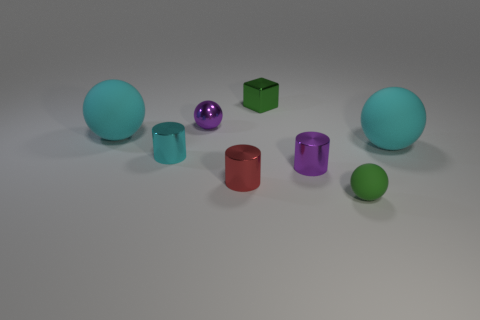There is a metal block that is the same color as the tiny rubber thing; what is its size?
Your answer should be compact. Small. Is there a large cyan object that has the same shape as the tiny cyan object?
Keep it short and to the point. No. What color is the metal ball that is the same size as the green matte sphere?
Keep it short and to the point. Purple. Is the number of small cyan metal things right of the green shiny object less than the number of small green objects to the right of the purple metal cylinder?
Make the answer very short. Yes. Is the size of the object behind the purple metal sphere the same as the tiny cyan thing?
Make the answer very short. Yes. There is a tiny object that is in front of the tiny red metal cylinder; what is its shape?
Give a very brief answer. Sphere. Are there more small cubes than objects?
Offer a terse response. No. Is the color of the object that is behind the purple metallic ball the same as the small matte object?
Make the answer very short. Yes. How many things are either rubber balls right of the small purple sphere or tiny shiny cylinders that are right of the block?
Keep it short and to the point. 3. How many green things are both behind the tiny cyan metal thing and in front of the red thing?
Keep it short and to the point. 0. 